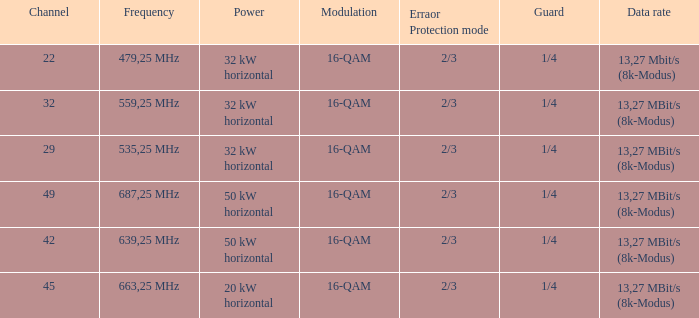When the power on channel 32 is set to 32 kw horizontally, what is the modulation level? 16-QAM. 